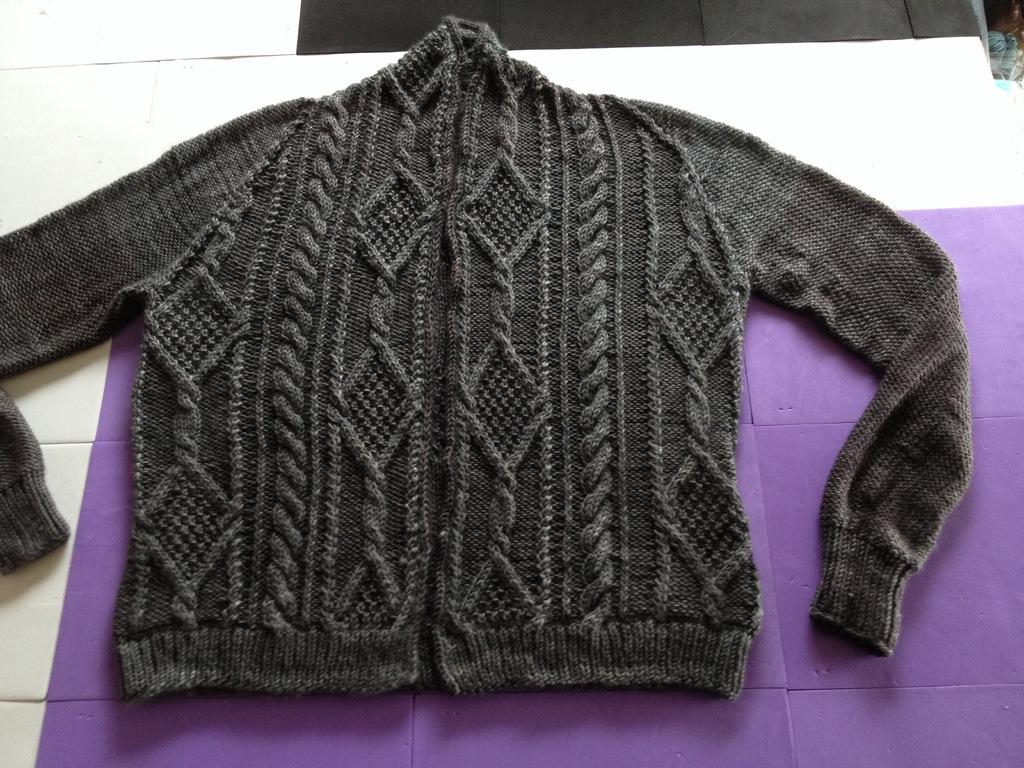What type of clothing is visible in the image? There is a wool cardigan in the image. Where is the wool cardigan located? The wool cardigan is on the floor or on an object. What type of hill can be seen in the background of the image? There is no hill visible in the image; it only features a wool cardigan on the floor or on an object. 